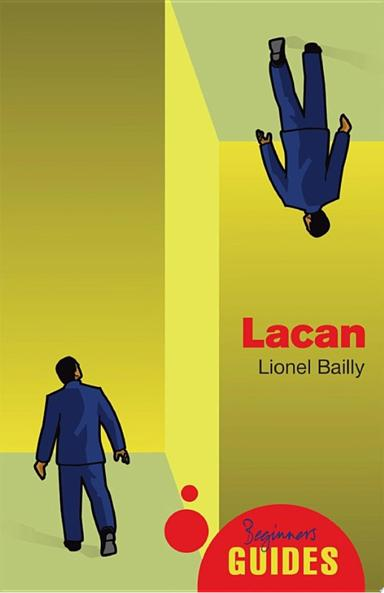Can you explain why the background is split into two different shades? The split background with two contrasting shades might illustrate the dichotomy in human psyche, a central theme in psychoanalysis. It visually implies the conflict and division inherent in human nature as analyzed in Lacanian theory. 